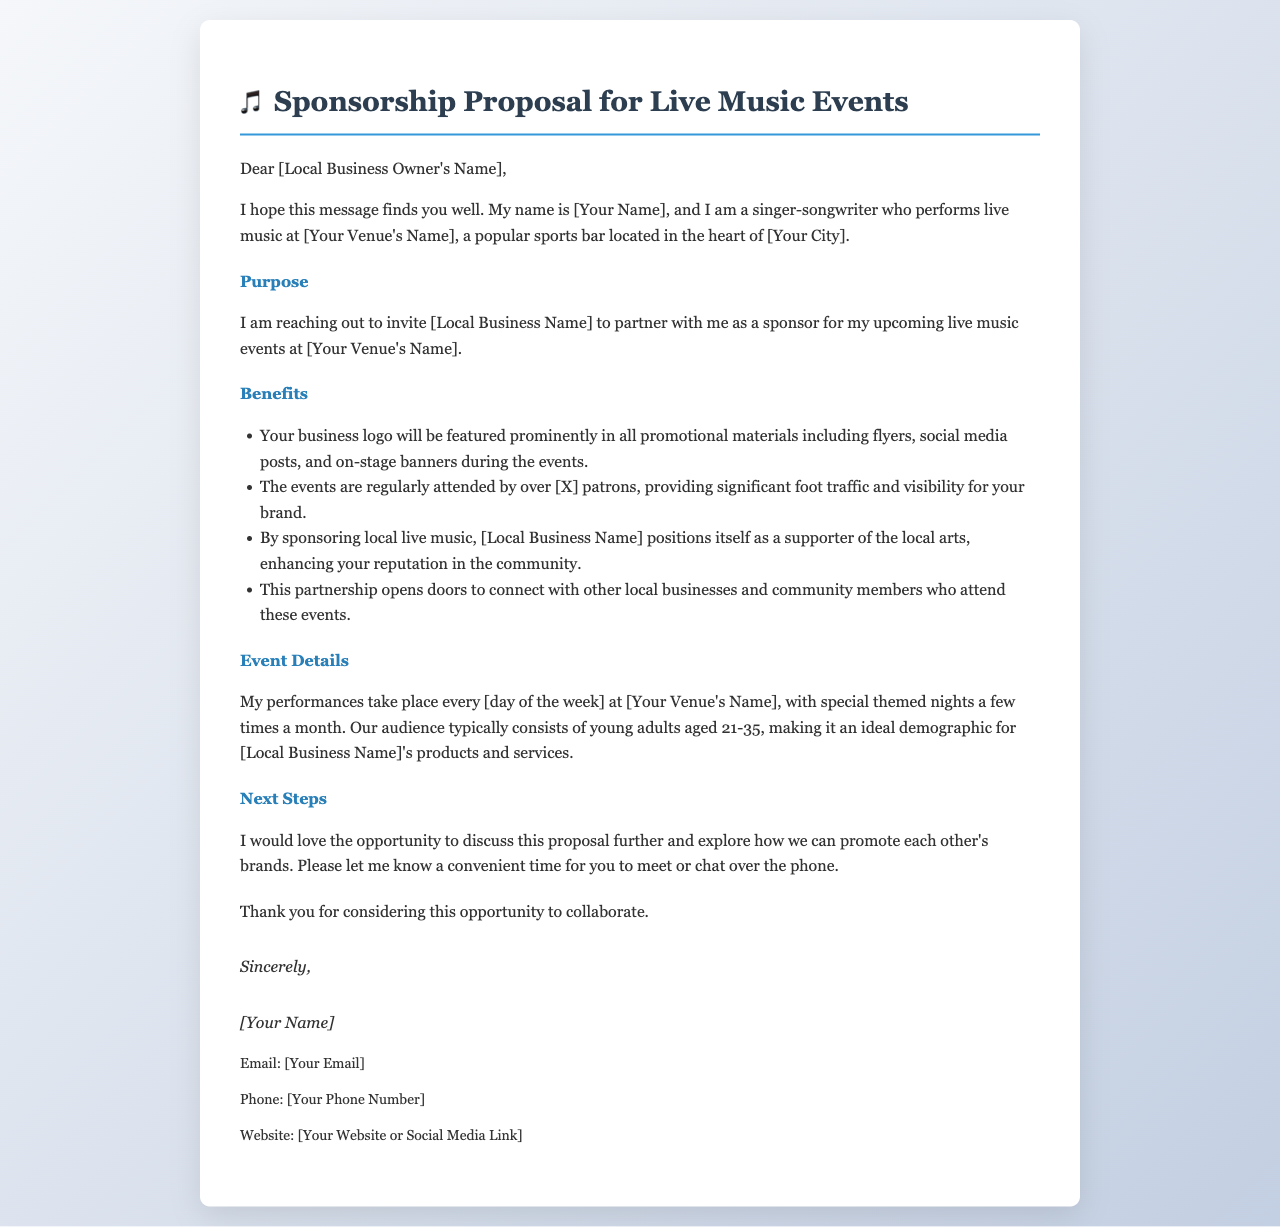What is the name of the sender? The sender's name is referenced in the introduction as "[Your Name]."
Answer: [Your Name] What is the venue's name? The venue where the performances take place is referred to as "[Your Venue's Name]."
Answer: [Your Venue's Name] On which day of the week do performances take place? The performances are mentioned to occur every "[day of the week]."
Answer: [day of the week] What age group constitutes the typical audience? The document specifies that the audience typically consists of young adults aged "21-35."
Answer: 21-35 What will be featured in promotional materials? The proposal states that the business logo will be featured prominently in "all promotional materials."
Answer: all promotional materials What is the main purpose of the letter? The purpose of the letter is to invite "[Local Business Name]" to partner as a sponsor for live music events.
Answer: [Local Business Name] What does the partnership position the business as? By sponsoring local live music, the business positions itself as a "supporter of the local arts."
Answer: supporter of the local arts What is the first step suggested in the next steps section? The next step suggested is to discuss the proposal further and explore how to "promote each other's brands."
Answer: promote each other's brands How many patrons are regularly attended at the events? The document mentions that events are regularly attended by over "[X]" patrons.
Answer: [X] 